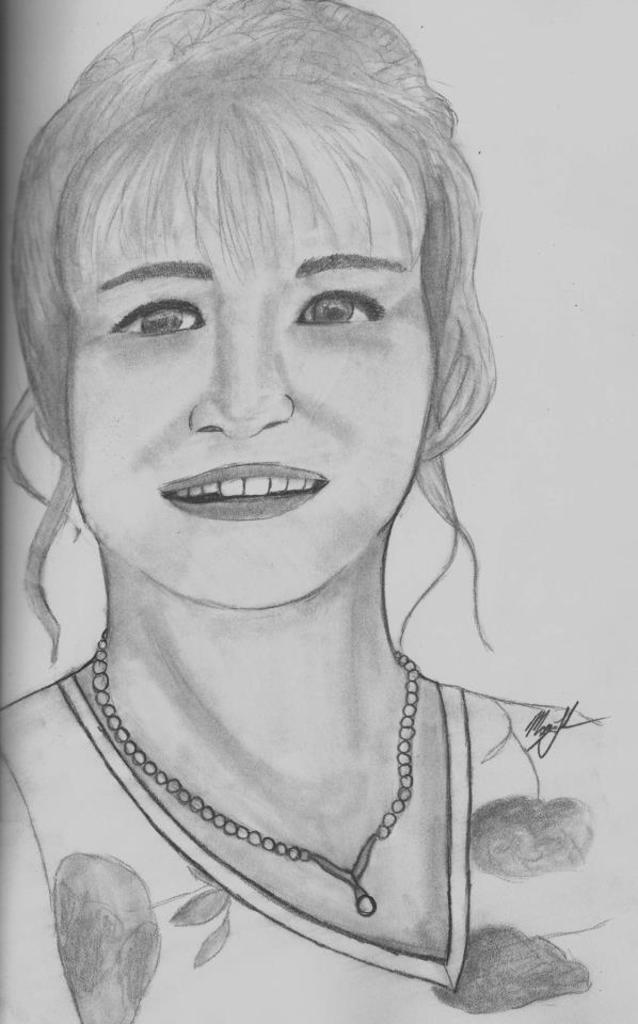What is the main subject of the image? The main subject of the image is a drawing of a lady. What can be seen around the lady's neck in the drawing? The lady has a chain around her neck in the drawing. How many teeth does the lady have in the drawing? The image is a drawing, and it does not show the lady's teeth, so we cannot determine the number of teeth she has. 